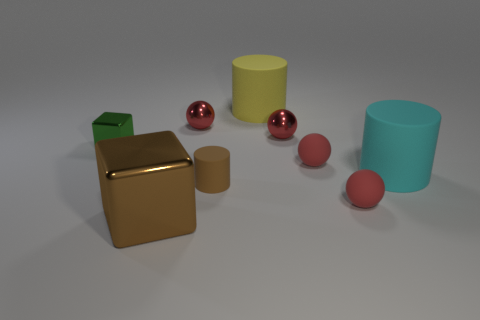The thing that is the same color as the big metal cube is what size?
Ensure brevity in your answer.  Small. What number of tiny red metal spheres are left of the yellow object?
Offer a terse response. 1. Are the small red sphere that is left of the large yellow rubber cylinder and the cylinder that is behind the green shiny thing made of the same material?
Ensure brevity in your answer.  No. Are there more yellow rubber cylinders that are on the left side of the tiny brown cylinder than brown matte things that are in front of the big brown thing?
Make the answer very short. No. There is a cube that is the same color as the small matte cylinder; what is it made of?
Your answer should be very brief. Metal. Is there anything else that has the same shape as the green thing?
Your response must be concise. Yes. What is the cylinder that is both in front of the small green object and to the left of the big cyan rubber cylinder made of?
Keep it short and to the point. Rubber. Are the small green cube and the tiny red object that is in front of the small rubber cylinder made of the same material?
Make the answer very short. No. Are there any other things that are the same size as the cyan cylinder?
Your response must be concise. Yes. How many objects are either large yellow things or rubber spheres in front of the green metal object?
Provide a short and direct response. 3. 